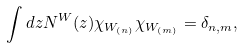<formula> <loc_0><loc_0><loc_500><loc_500>\int d z N ^ { W } ( z ) \chi _ { W _ { ( n ) } } \chi _ { W _ { ( m ) } } = \delta _ { n , m } ,</formula> 